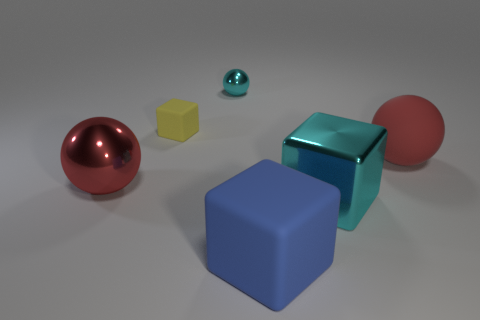How many cubes are either rubber objects or small yellow matte things?
Your answer should be compact. 2. What number of cyan objects have the same material as the blue thing?
Offer a terse response. 0. Does the big sphere that is to the right of the yellow object have the same material as the blue thing right of the red shiny object?
Give a very brief answer. Yes. There is a block that is behind the big sphere to the left of the tiny shiny thing; how many big spheres are left of it?
Keep it short and to the point. 1. Does the metallic sphere that is to the left of the small shiny ball have the same color as the large rubber thing that is to the right of the large blue thing?
Your answer should be compact. Yes. Is there anything else of the same color as the tiny matte thing?
Provide a short and direct response. No. What color is the large sphere that is on the right side of the object that is left of the tiny yellow rubber thing?
Give a very brief answer. Red. Is there a large matte cylinder?
Your answer should be compact. No. The metallic thing that is both right of the small rubber thing and in front of the tiny cyan ball is what color?
Give a very brief answer. Cyan. Is the size of the red thing behind the large metal sphere the same as the rubber object in front of the cyan block?
Your answer should be very brief. Yes. 